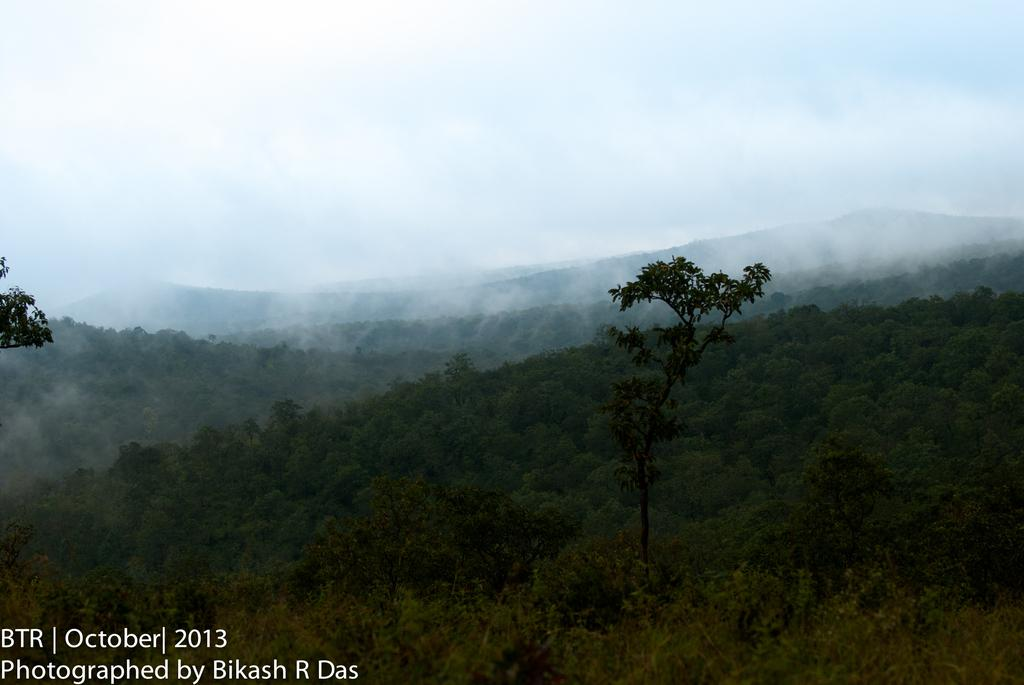What type of vegetation can be seen in the image? There are plants and trees in the image. What type of landscape feature is visible in the image? There are hills visible in the image. What atmospheric condition is present in the image? There is fog in the image. What part of the natural environment is visible in the image? The sky is visible in the image. What type of invention can be seen in the image? There is no invention present in the image; it features plants, trees, hills, fog, and the sky. What type of soda is being served in the image? There is no soda present in the image; it features plants, trees, hills, fog, and the sky. 